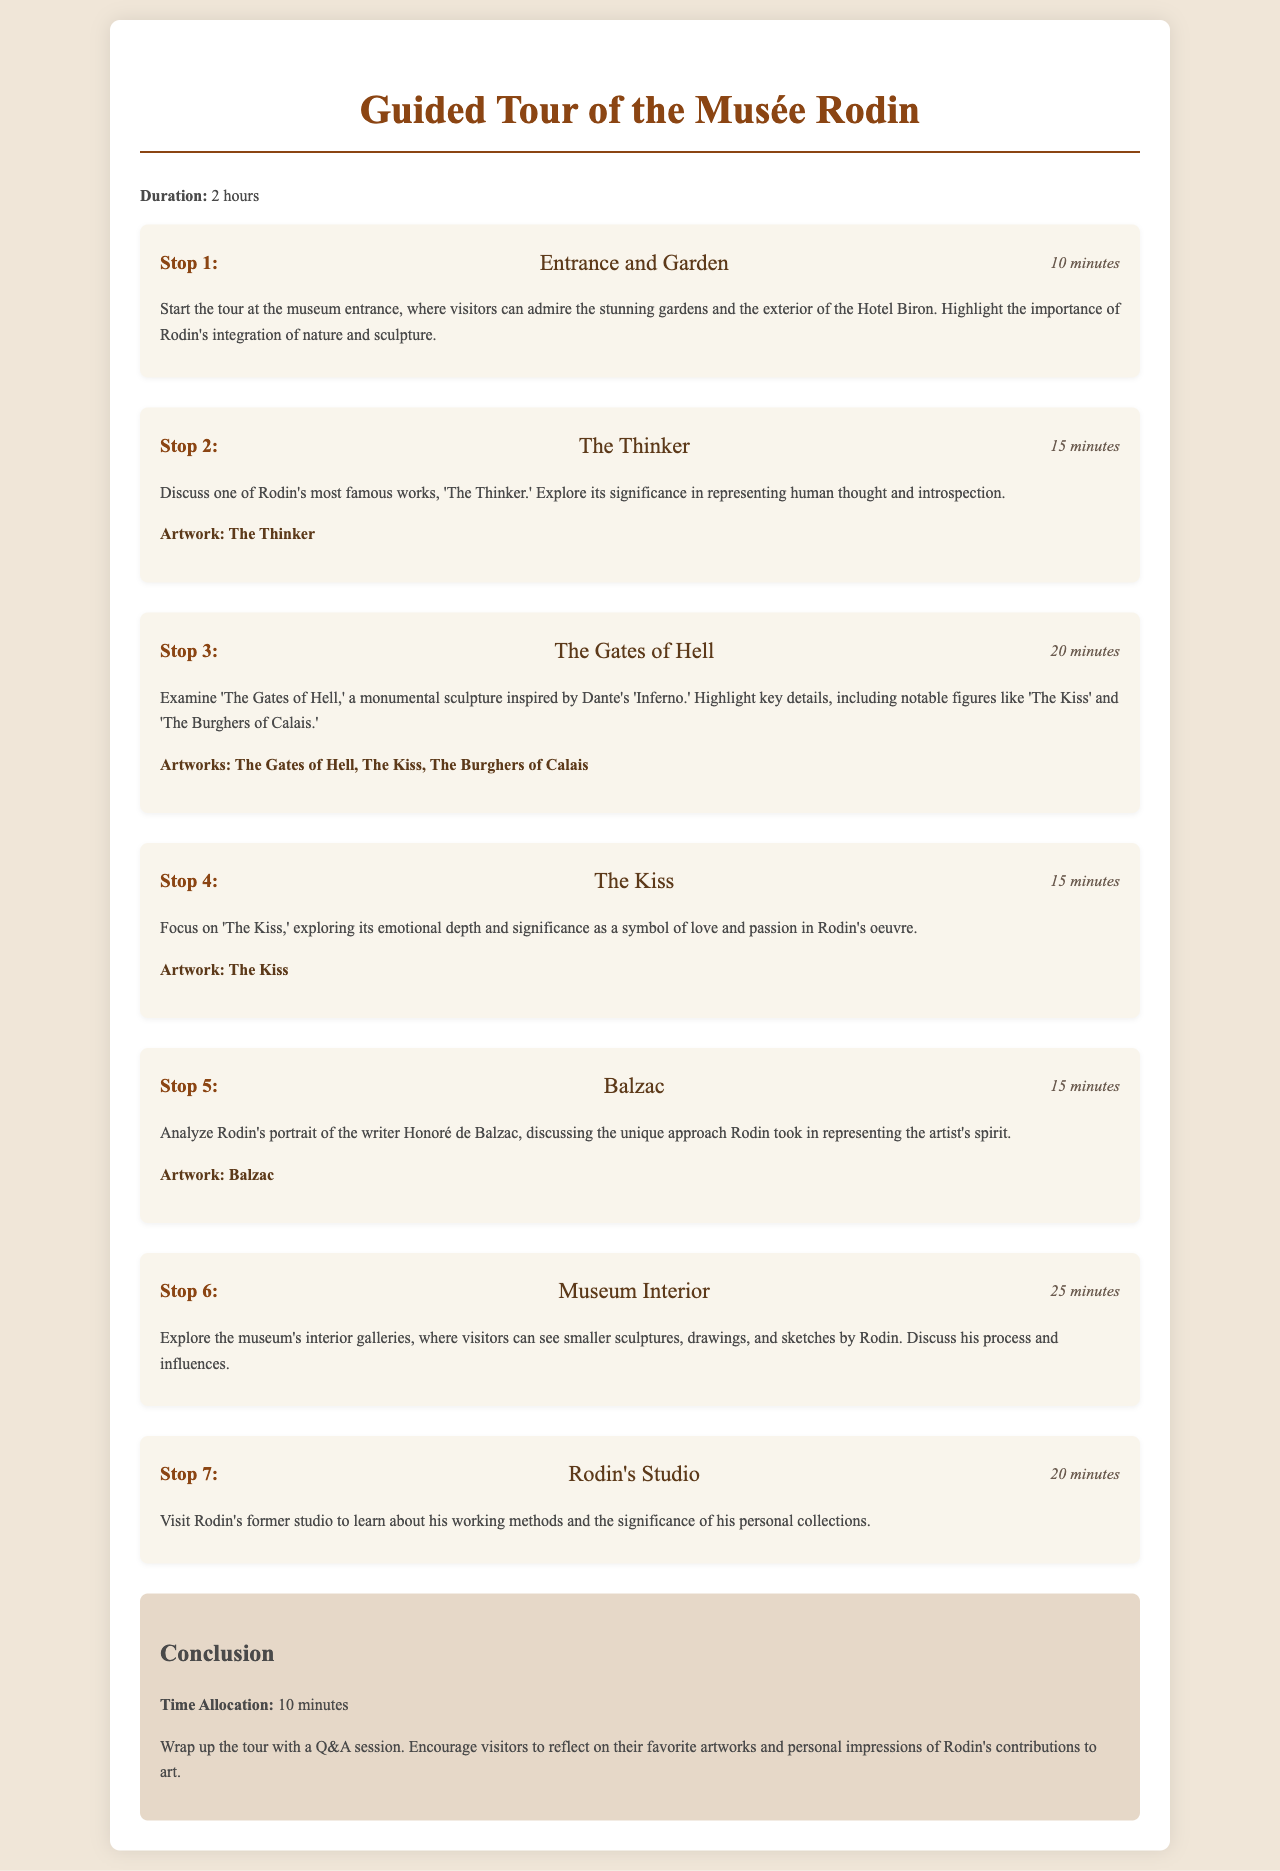What is the duration of the tour? The duration of the tour is explicitly stated in the document as 2 hours.
Answer: 2 hours How long do we allocate for the entrance and garden stop? The time allocation for the entrance and garden stop is detailed in the schedule.
Answer: 10 minutes What is the first artwork discussed in the tour? The first artwork highlighted in the tour is mentioned as 'The Thinker' during the second stop.
Answer: The Thinker How many minutes are spent on 'The Gates of Hell'? The document specifies the time allocation for this stop, which is derived from the structured itinerary.
Answer: 20 minutes Which stop focuses on the emotional depth of a sculpture? This question requires understanding that 'The Kiss' is highlighted for its emotional depth, as per the description.
Answer: The Kiss What studio does the tour visit that belonged to Rodin? The reference to Rodin's working location is clearly outlined in the tour stops.
Answer: Rodin's Studio What concludes the tour? The conclusion section indicates a specific activity that wraps up the entire experience.
Answer: Q&A session What artworks are included in the discussion of 'The Gates of Hell'? The document lists notable figures associated with this artwork, emphasizing the key pieces involved.
Answer: The Gates of Hell, The Kiss, The Burghers of Calais 